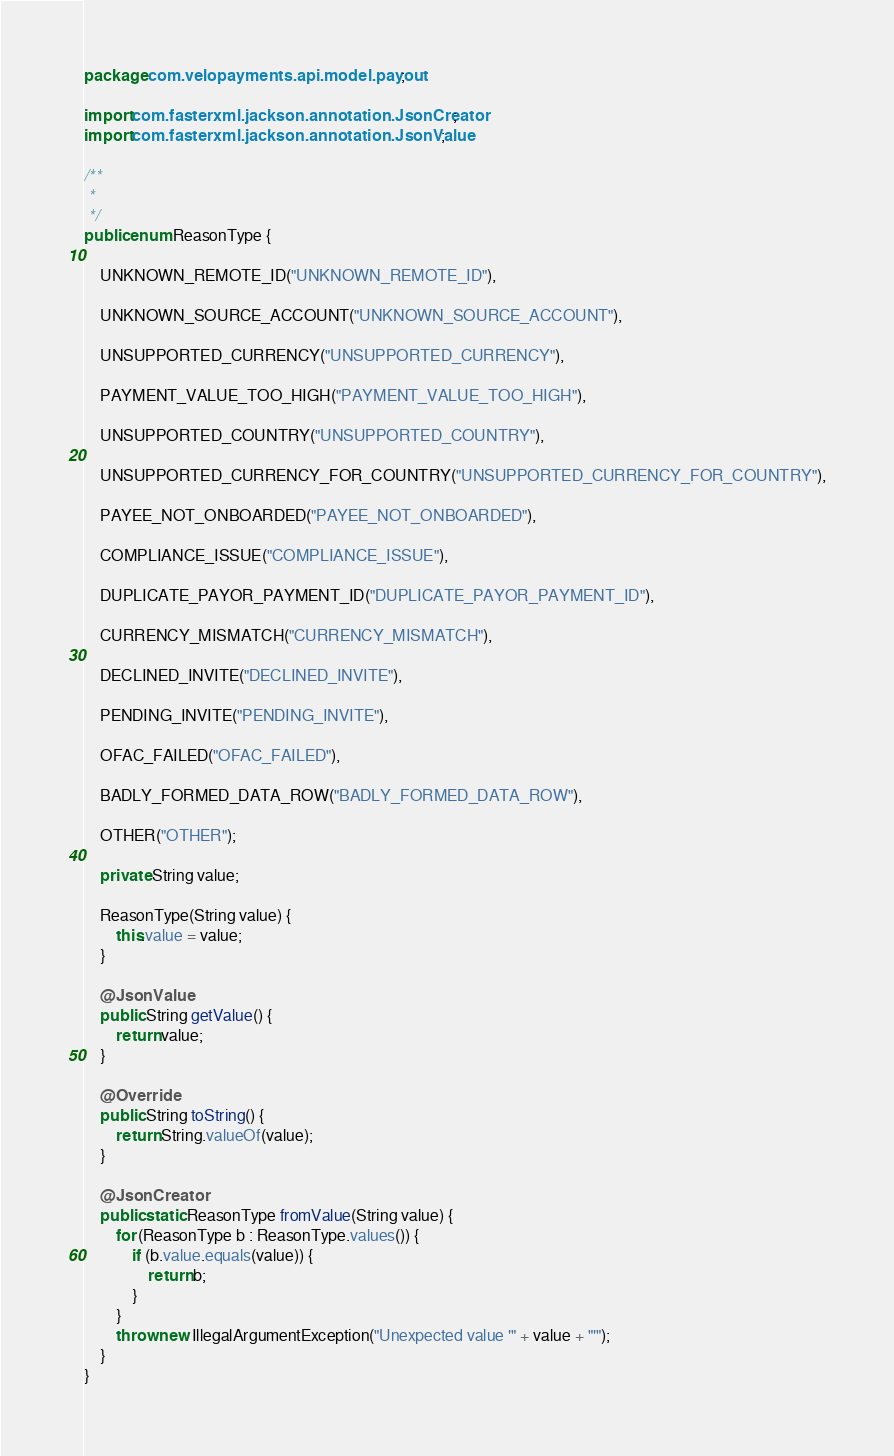<code> <loc_0><loc_0><loc_500><loc_500><_Java_>package com.velopayments.api.model.payout;

import com.fasterxml.jackson.annotation.JsonCreator;
import com.fasterxml.jackson.annotation.JsonValue;

/**
 *
 */
public enum ReasonType {

    UNKNOWN_REMOTE_ID("UNKNOWN_REMOTE_ID"),

    UNKNOWN_SOURCE_ACCOUNT("UNKNOWN_SOURCE_ACCOUNT"),

    UNSUPPORTED_CURRENCY("UNSUPPORTED_CURRENCY"),

    PAYMENT_VALUE_TOO_HIGH("PAYMENT_VALUE_TOO_HIGH"),

    UNSUPPORTED_COUNTRY("UNSUPPORTED_COUNTRY"),

    UNSUPPORTED_CURRENCY_FOR_COUNTRY("UNSUPPORTED_CURRENCY_FOR_COUNTRY"),

    PAYEE_NOT_ONBOARDED("PAYEE_NOT_ONBOARDED"),

    COMPLIANCE_ISSUE("COMPLIANCE_ISSUE"),

    DUPLICATE_PAYOR_PAYMENT_ID("DUPLICATE_PAYOR_PAYMENT_ID"),

    CURRENCY_MISMATCH("CURRENCY_MISMATCH"),

    DECLINED_INVITE("DECLINED_INVITE"),

    PENDING_INVITE("PENDING_INVITE"),

    OFAC_FAILED("OFAC_FAILED"),

    BADLY_FORMED_DATA_ROW("BADLY_FORMED_DATA_ROW"),

    OTHER("OTHER");

    private String value;

    ReasonType(String value) {
        this.value = value;
    }

    @JsonValue
    public String getValue() {
        return value;
    }

    @Override
    public String toString() {
        return String.valueOf(value);
    }

    @JsonCreator
    public static ReasonType fromValue(String value) {
        for (ReasonType b : ReasonType.values()) {
            if (b.value.equals(value)) {
                return b;
            }
        }
        throw new IllegalArgumentException("Unexpected value '" + value + "'");
    }
}
</code> 